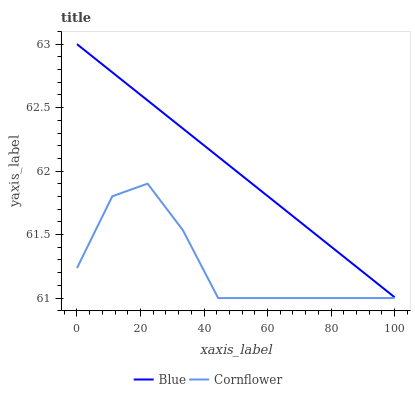Does Cornflower have the minimum area under the curve?
Answer yes or no. Yes. Does Blue have the maximum area under the curve?
Answer yes or no. Yes. Does Cornflower have the maximum area under the curve?
Answer yes or no. No. Is Blue the smoothest?
Answer yes or no. Yes. Is Cornflower the roughest?
Answer yes or no. Yes. Is Cornflower the smoothest?
Answer yes or no. No. Does Blue have the highest value?
Answer yes or no. Yes. Does Cornflower have the highest value?
Answer yes or no. No. Is Cornflower less than Blue?
Answer yes or no. Yes. Is Blue greater than Cornflower?
Answer yes or no. Yes. Does Cornflower intersect Blue?
Answer yes or no. No. 